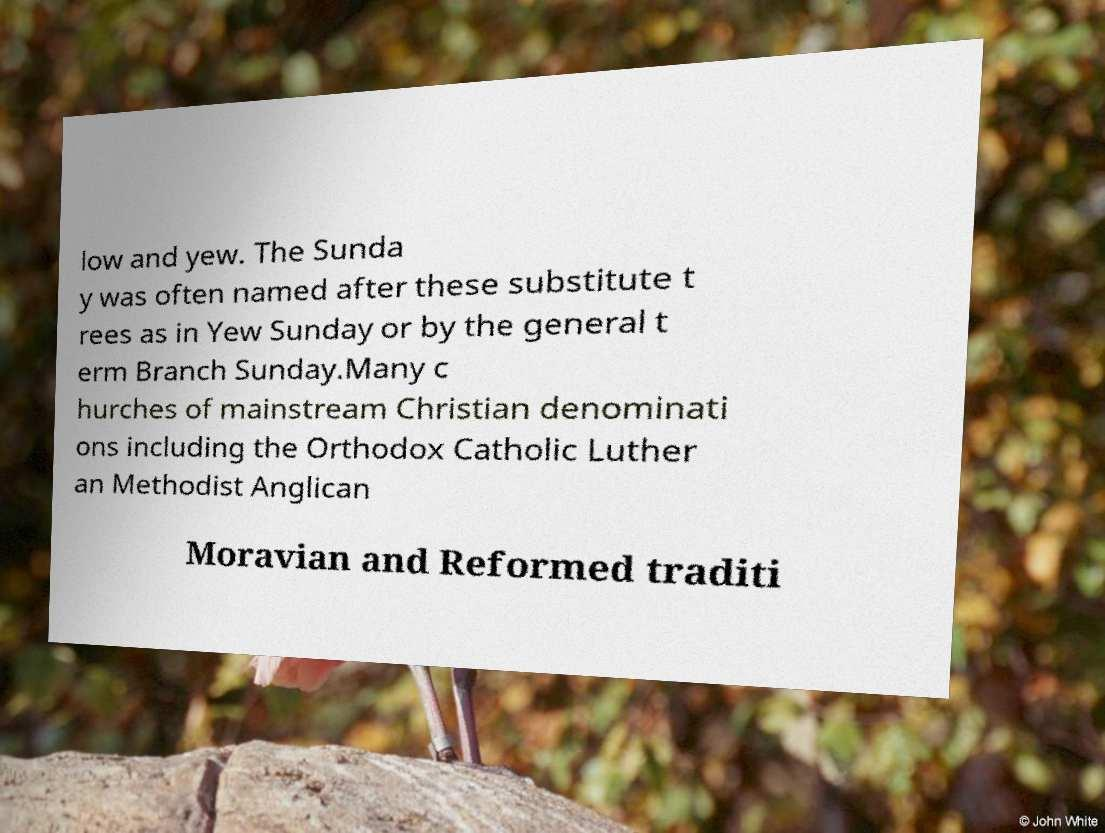What messages or text are displayed in this image? I need them in a readable, typed format. low and yew. The Sunda y was often named after these substitute t rees as in Yew Sunday or by the general t erm Branch Sunday.Many c hurches of mainstream Christian denominati ons including the Orthodox Catholic Luther an Methodist Anglican Moravian and Reformed traditi 